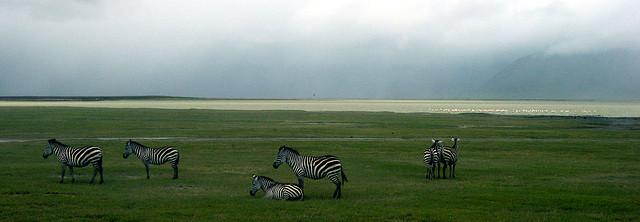What is on the grass? Please explain your reasoning. zebras. The animals are on it. 